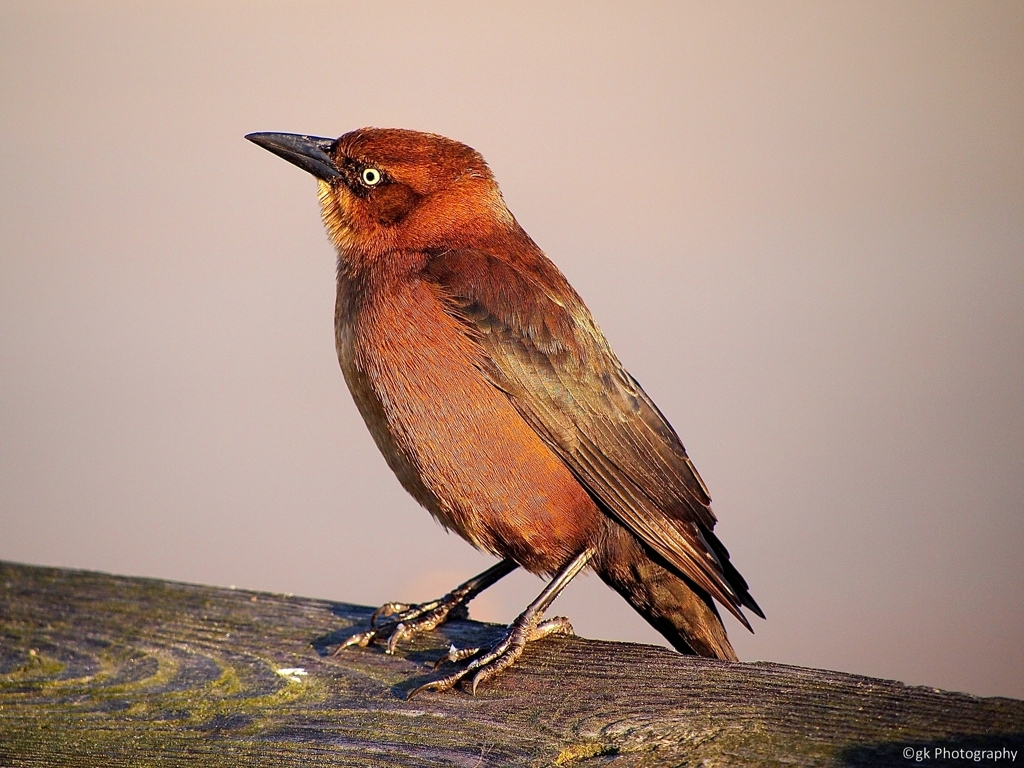Can you tell me what species this bird might be? While I can provide information based on the image, identifying species solely from an image can sometimes be challenging without expertise. This bird, with its distinctive rusty-red to brown coloring and a slightly pointed beak, could belong to the category of passerine birds, which are common in many environments. Conducting research with more specific details or consulting with an ornithologist would likely yield a precise identification. What aspects of its physical appearance suggest its natural habitat? The bird's plumage and coloration are often indicative of its habitat. The brownish tones found in this bird could suggest a preference for woodland or brushland environments, where such colors would blend effectively with the surroundings. The structure of its feet and the shape of its bill could also provide insights into its feeding habits and the types of environments it frequents. 